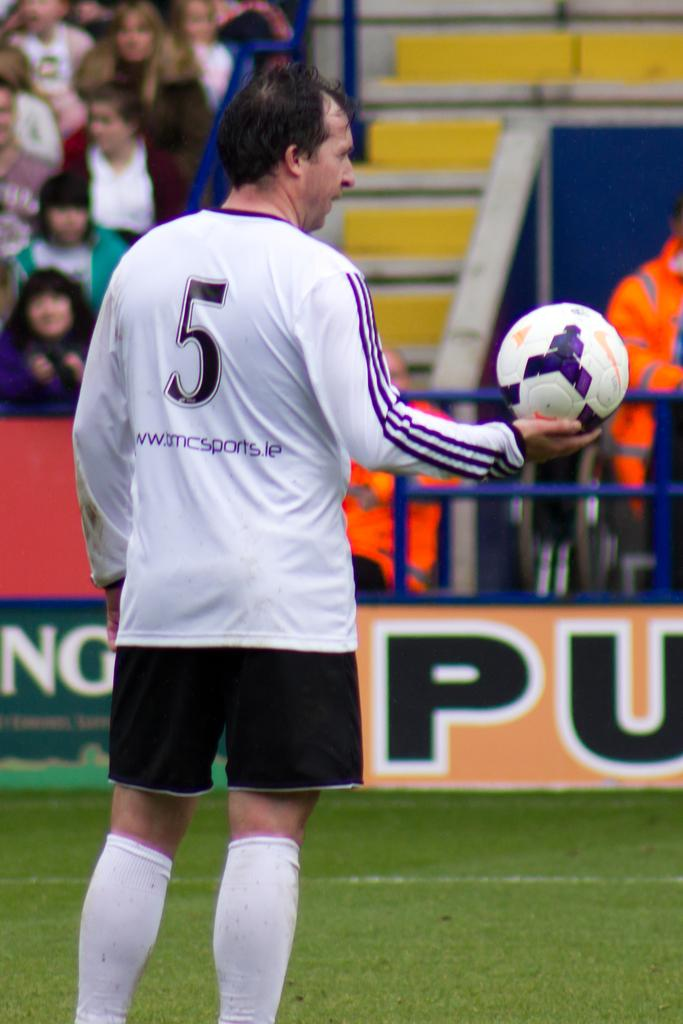Provide a one-sentence caption for the provided image. A man wearing a white number 5 jersey holding the soccer ball in his right hand. 